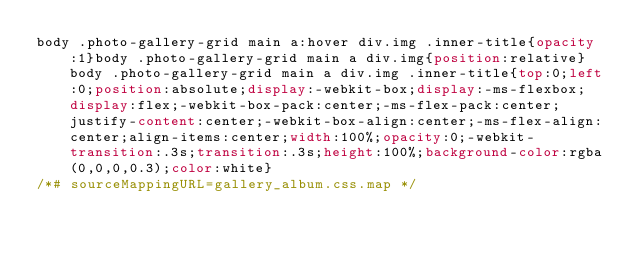Convert code to text. <code><loc_0><loc_0><loc_500><loc_500><_CSS_>body .photo-gallery-grid main a:hover div.img .inner-title{opacity:1}body .photo-gallery-grid main a div.img{position:relative}body .photo-gallery-grid main a div.img .inner-title{top:0;left:0;position:absolute;display:-webkit-box;display:-ms-flexbox;display:flex;-webkit-box-pack:center;-ms-flex-pack:center;justify-content:center;-webkit-box-align:center;-ms-flex-align:center;align-items:center;width:100%;opacity:0;-webkit-transition:.3s;transition:.3s;height:100%;background-color:rgba(0,0,0,0.3);color:white}
/*# sourceMappingURL=gallery_album.css.map */</code> 